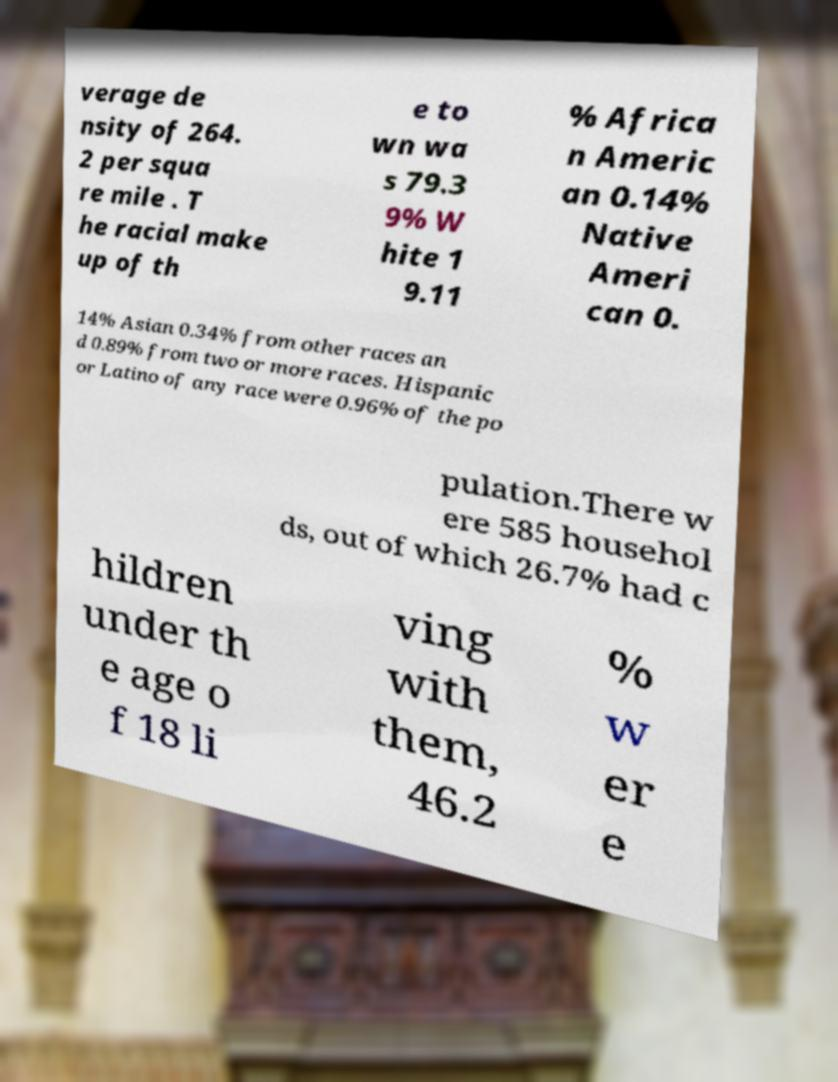Could you assist in decoding the text presented in this image and type it out clearly? verage de nsity of 264. 2 per squa re mile . T he racial make up of th e to wn wa s 79.3 9% W hite 1 9.11 % Africa n Americ an 0.14% Native Ameri can 0. 14% Asian 0.34% from other races an d 0.89% from two or more races. Hispanic or Latino of any race were 0.96% of the po pulation.There w ere 585 househol ds, out of which 26.7% had c hildren under th e age o f 18 li ving with them, 46.2 % w er e 